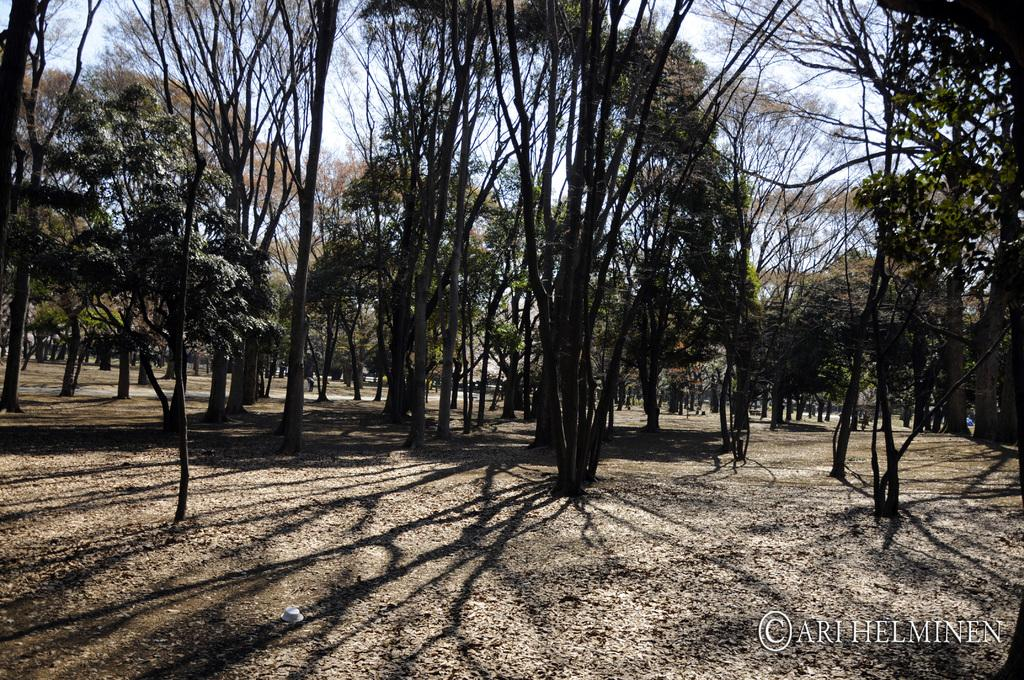What type of vegetation can be seen in the image? There are trees in the image. What is visible at the top of the image? The sky is visible at the top of the image. What is visible at the bottom of the image? The ground is visible at the bottom of the image. What type of natural debris can be seen in the image? Dried leaves are present in the image. Where is the text located in the image? The text is at the bottom right of the image. How many cows are grazing in the image? There are no cows present in the image. What type of jam is being spread on the worm in the image? There is no jam or worm present in the image. 